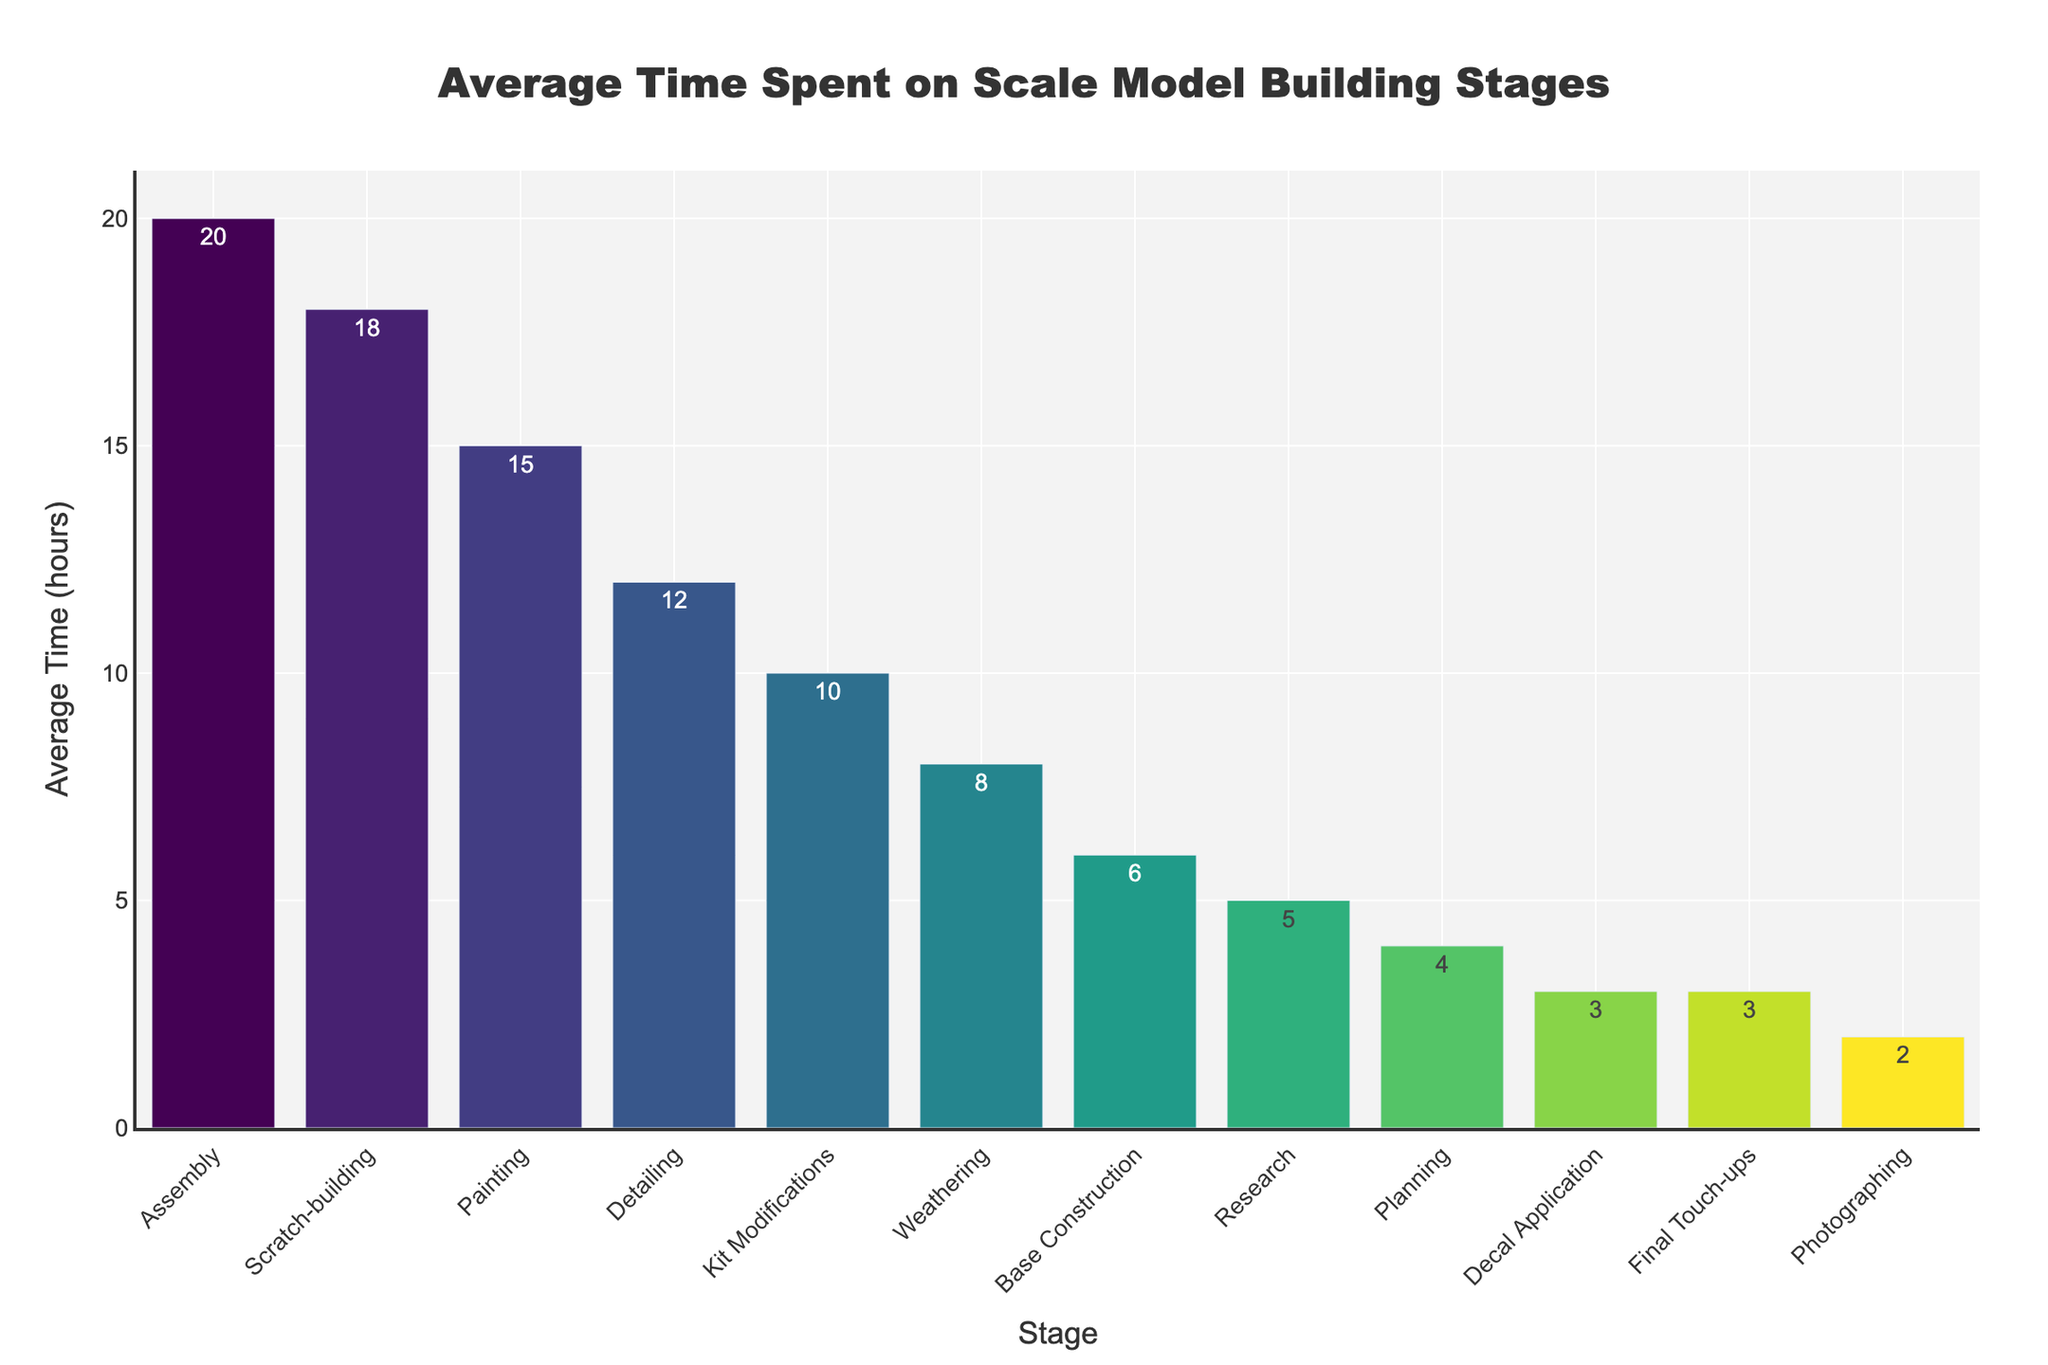Which stage takes the most time on average? The highest bar on the chart represents the stage that takes the most time on average, which is Assembly with 20 hours.
Answer: Assembly Which stage takes the least time on average? The shortest bar on the chart represents the stage that takes the least time on average, which is Photographing with 2 hours.
Answer: Photographing How much more time does Assembly take compared to Detailing? Assembly takes 20 hours and Detailing takes 12 hours. The difference is 20 - 12 = 8 hours.
Answer: 8 hours What is the average time spent on Painting and Weathering combined? Painting takes 15 hours and Weathering takes 8 hours. The combined time is 15 + 8 = 23 hours.
Answer: 23 hours Which stage has roughly half the average time spent on Assembly? Assembly takes 20 hours, so half of that is 10 hours. Kit Modifications, which takes approximately 10 hours, matches this criterion.
Answer: Kit Modifications List the stages that take more time on average than Research. Research takes 5 hours. The stages that take more time are Assembly (20), Painting (15), Weathering (8), Detailing (12), Scratch-building (18), and Kit Modifications (10).
Answer: Assembly, Painting, Weathering, Detailing, Scratch-building, Kit Modifications What is the total average time spent on Planning, Research and Photographing? Planning takes 4 hours, Research takes 5 hours and Photographing takes 2 hours. The total is 4 + 5 + 2 = 11 hours.
Answer: 11 hours Is the color of the bar for Painting darker or lighter than the bar for Planning? In the Viridis color scale used, lighter colors represent higher values. Painting (15 hours) has a higher average time than Planning (4 hours), so the bar for Painting is lighter than the bar for Planning.
Answer: Lighter How does the height of the bar for Kit Modifications compare to that of Base Construction? Kit Modifications takes 10 hours while Base Construction takes 6 hours. The height of the bar for Kit Modifications is taller than that for Base Construction.
Answer: Taller If you add the average times for Scratch-building, Kit Modifications, and Final Touch-ups, what is the result? Scratch-building takes 18 hours, Kit Modifications take 10 hours, and Final Touch-ups take 3 hours. The total is 18 + 10 + 3 = 31 hours.
Answer: 31 hours 